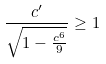<formula> <loc_0><loc_0><loc_500><loc_500>\frac { c ^ { \prime } } { \sqrt { 1 - \frac { c ^ { 6 } } { 9 } } } \geq 1</formula> 